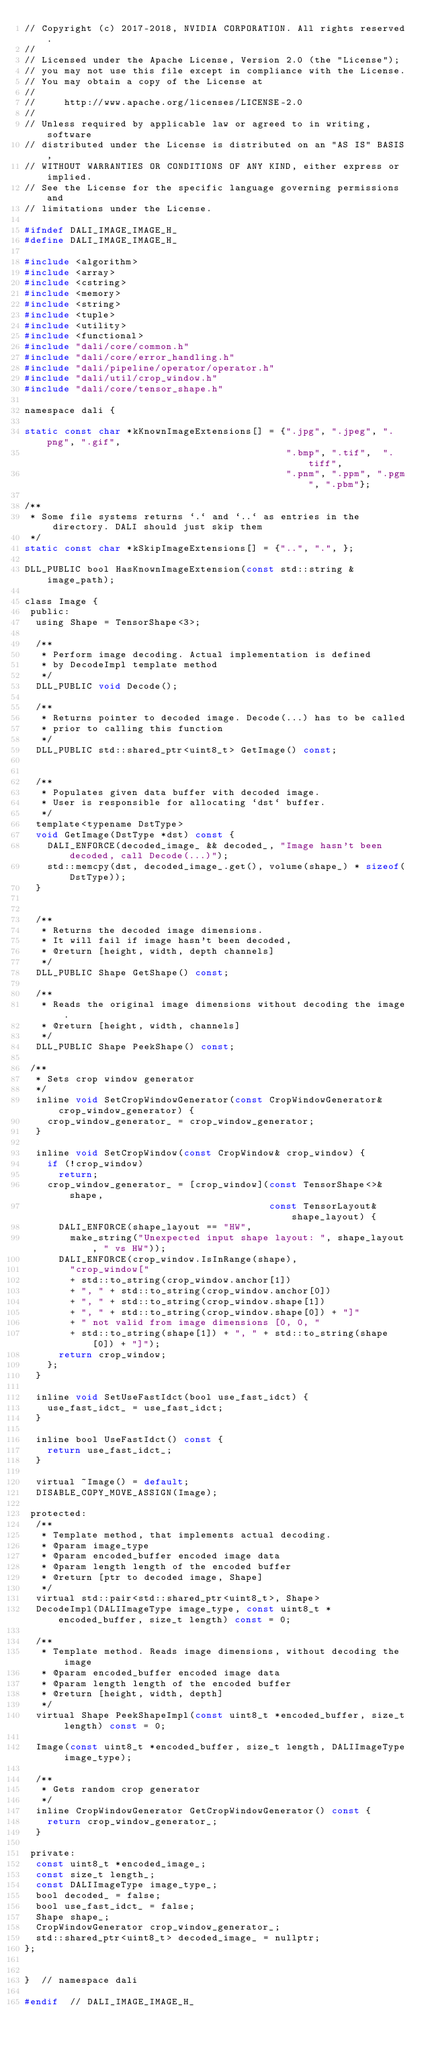Convert code to text. <code><loc_0><loc_0><loc_500><loc_500><_C_>// Copyright (c) 2017-2018, NVIDIA CORPORATION. All rights reserved.
//
// Licensed under the Apache License, Version 2.0 (the "License");
// you may not use this file except in compliance with the License.
// You may obtain a copy of the License at
//
//     http://www.apache.org/licenses/LICENSE-2.0
//
// Unless required by applicable law or agreed to in writing, software
// distributed under the License is distributed on an "AS IS" BASIS,
// WITHOUT WARRANTIES OR CONDITIONS OF ANY KIND, either express or implied.
// See the License for the specific language governing permissions and
// limitations under the License.

#ifndef DALI_IMAGE_IMAGE_H_
#define DALI_IMAGE_IMAGE_H_

#include <algorithm>
#include <array>
#include <cstring>
#include <memory>
#include <string>
#include <tuple>
#include <utility>
#include <functional>
#include "dali/core/common.h"
#include "dali/core/error_handling.h"
#include "dali/pipeline/operator/operator.h"
#include "dali/util/crop_window.h"
#include "dali/core/tensor_shape.h"

namespace dali {

static const char *kKnownImageExtensions[] = {".jpg", ".jpeg", ".png", ".gif",
                                              ".bmp", ".tif",  ".tiff",
                                              ".pnm", ".ppm", ".pgm", ".pbm"};

/**
 * Some file systems returns `.` and `..` as entries in the directory. DALI should just skip them
 */
static const char *kSkipImageExtensions[] = {"..", ".", };

DLL_PUBLIC bool HasKnownImageExtension(const std::string &image_path);

class Image {
 public:
  using Shape = TensorShape<3>;

  /**
   * Perform image decoding. Actual implementation is defined
   * by DecodeImpl template method
   */
  DLL_PUBLIC void Decode();

  /**
   * Returns pointer to decoded image. Decode(...) has to be called
   * prior to calling this function
   */
  DLL_PUBLIC std::shared_ptr<uint8_t> GetImage() const;


  /**
   * Populates given data buffer with decoded image.
   * User is responsible for allocating `dst` buffer.
   */
  template<typename DstType>
  void GetImage(DstType *dst) const {
    DALI_ENFORCE(decoded_image_ && decoded_, "Image hasn't been decoded, call Decode(...)");
    std::memcpy(dst, decoded_image_.get(), volume(shape_) * sizeof(DstType));
  }


  /**
   * Returns the decoded image dimensions.
   * It will fail if image hasn't been decoded,
   * @return [height, width, depth channels]
   */
  DLL_PUBLIC Shape GetShape() const;

  /**
   * Reads the original image dimensions without decoding the image.
   * @return [height, width, channels]
   */
  DLL_PUBLIC Shape PeekShape() const;

 /**
  * Sets crop window generator
  */
  inline void SetCropWindowGenerator(const CropWindowGenerator& crop_window_generator) {
    crop_window_generator_ = crop_window_generator;
  }

  inline void SetCropWindow(const CropWindow& crop_window) {
    if (!crop_window)
      return;
    crop_window_generator_ = [crop_window](const TensorShape<>& shape,
                                           const TensorLayout& shape_layout) {
      DALI_ENFORCE(shape_layout == "HW",
        make_string("Unexpected input shape layout: ", shape_layout, " vs HW"));
      DALI_ENFORCE(crop_window.IsInRange(shape),
        "crop_window["
        + std::to_string(crop_window.anchor[1])
        + ", " + std::to_string(crop_window.anchor[0])
        + ", " + std::to_string(crop_window.shape[1])
        + ", " + std::to_string(crop_window.shape[0]) + "]"
        + " not valid from image dimensions [0, 0, "
        + std::to_string(shape[1]) + ", " + std::to_string(shape[0]) + "]");
      return crop_window;
    };
  }

  inline void SetUseFastIdct(bool use_fast_idct) {
    use_fast_idct_ = use_fast_idct;
  }

  inline bool UseFastIdct() const {
    return use_fast_idct_;
  }

  virtual ~Image() = default;
  DISABLE_COPY_MOVE_ASSIGN(Image);

 protected:
  /**
   * Template method, that implements actual decoding.
   * @param image_type
   * @param encoded_buffer encoded image data
   * @param length length of the encoded buffer
   * @return [ptr to decoded image, Shape]
   */
  virtual std::pair<std::shared_ptr<uint8_t>, Shape>
  DecodeImpl(DALIImageType image_type, const uint8_t *encoded_buffer, size_t length) const = 0;

  /**
   * Template method. Reads image dimensions, without decoding the image
   * @param encoded_buffer encoded image data
   * @param length length of the encoded buffer
   * @return [height, width, depth]
   */
  virtual Shape PeekShapeImpl(const uint8_t *encoded_buffer, size_t length) const = 0;

  Image(const uint8_t *encoded_buffer, size_t length, DALIImageType image_type);

  /**
   * Gets random crop generator
   */
  inline CropWindowGenerator GetCropWindowGenerator() const {
    return crop_window_generator_;
  }

 private:
  const uint8_t *encoded_image_;
  const size_t length_;
  const DALIImageType image_type_;
  bool decoded_ = false;
  bool use_fast_idct_ = false;
  Shape shape_;
  CropWindowGenerator crop_window_generator_;
  std::shared_ptr<uint8_t> decoded_image_ = nullptr;
};


}  // namespace dali

#endif  // DALI_IMAGE_IMAGE_H_
</code> 